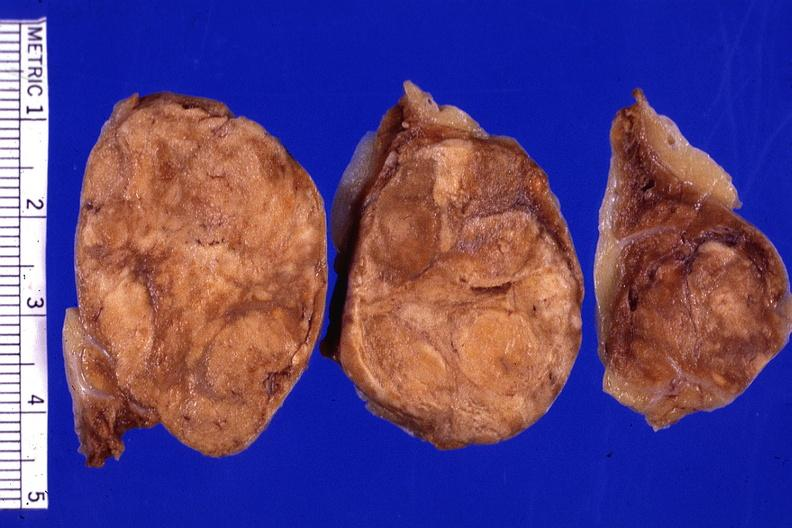s angiogram saphenous vein bypass graft present?
Answer the question using a single word or phrase. No 